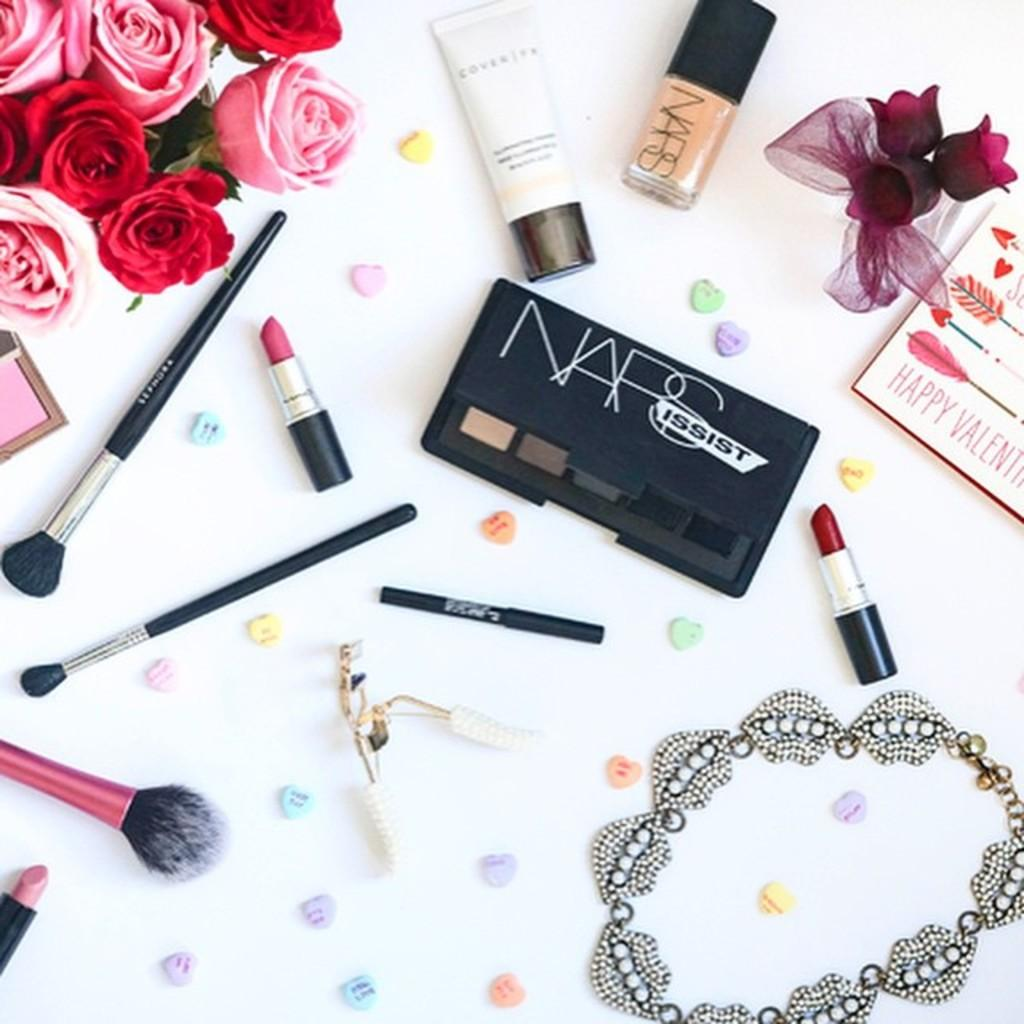<image>
Describe the image concisely. Roses, conversation hearts, jewelry and NAPS makeup is displayed along with a Happy Valentine's card. 